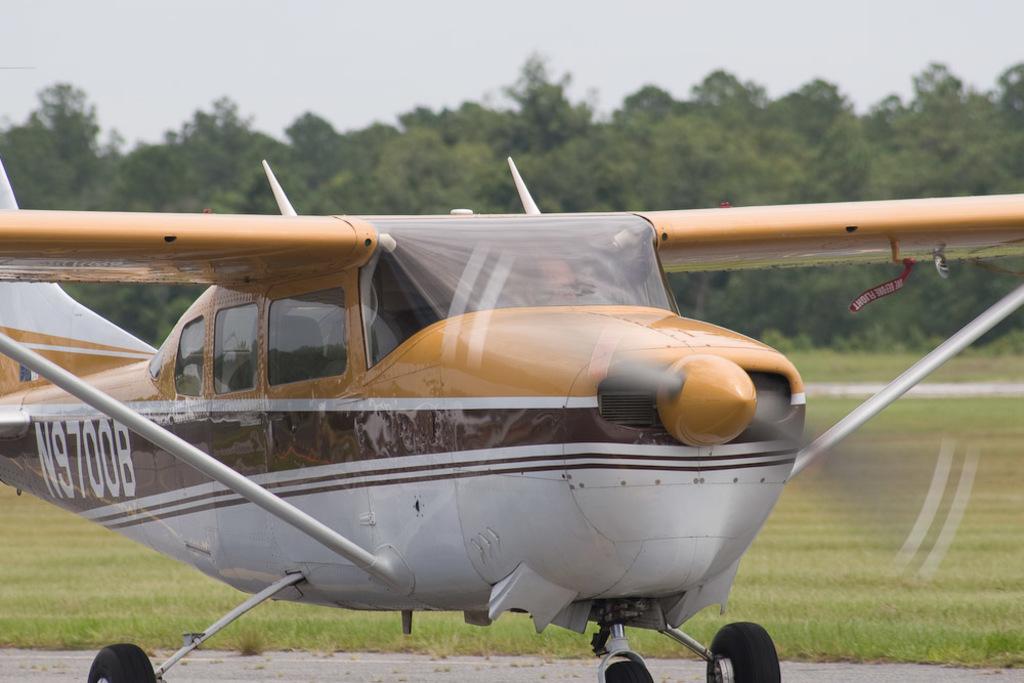What is this planes id number?
Your answer should be compact. N9700b. 